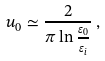Convert formula to latex. <formula><loc_0><loc_0><loc_500><loc_500>u _ { 0 } \simeq \frac { 2 } { \pi \ln \frac { \varepsilon _ { 0 } } { \varepsilon _ { i } } } \, ,</formula> 